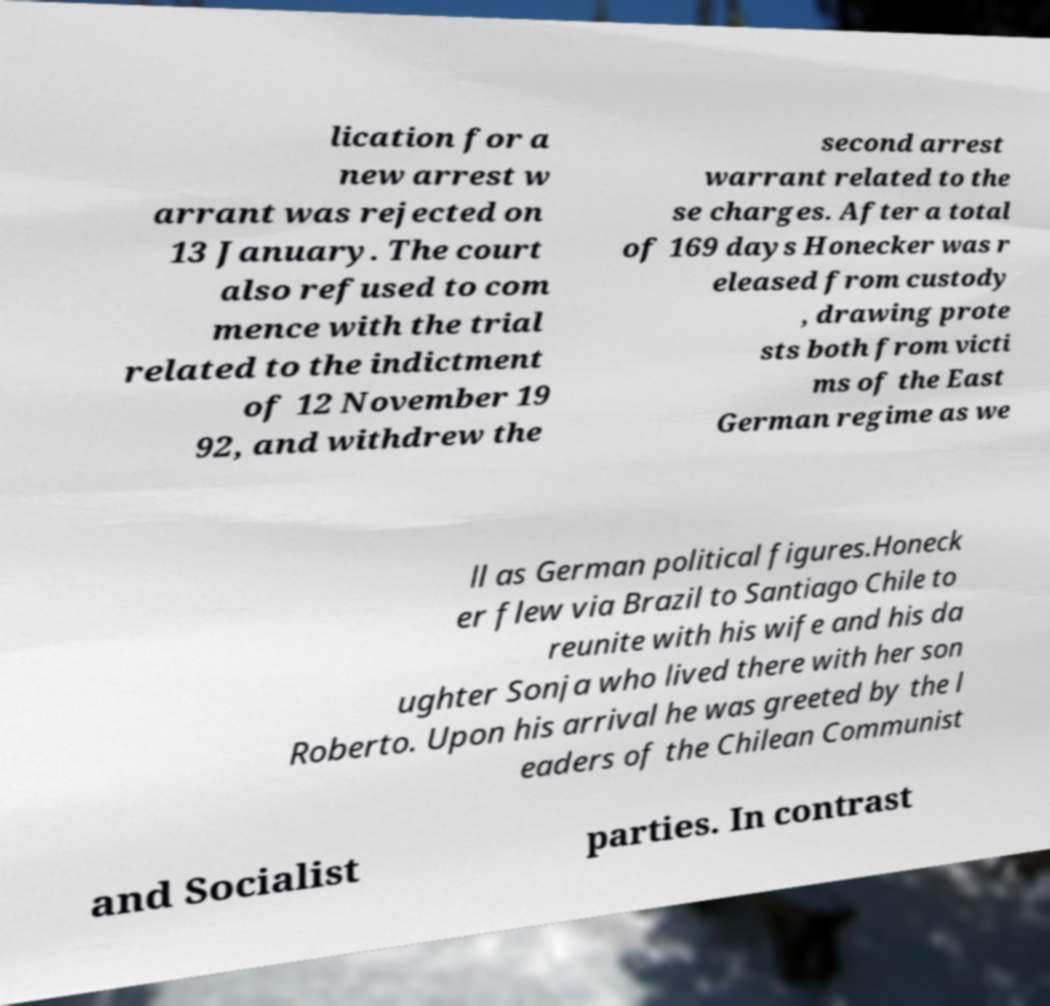What messages or text are displayed in this image? I need them in a readable, typed format. lication for a new arrest w arrant was rejected on 13 January. The court also refused to com mence with the trial related to the indictment of 12 November 19 92, and withdrew the second arrest warrant related to the se charges. After a total of 169 days Honecker was r eleased from custody , drawing prote sts both from victi ms of the East German regime as we ll as German political figures.Honeck er flew via Brazil to Santiago Chile to reunite with his wife and his da ughter Sonja who lived there with her son Roberto. Upon his arrival he was greeted by the l eaders of the Chilean Communist and Socialist parties. In contrast 